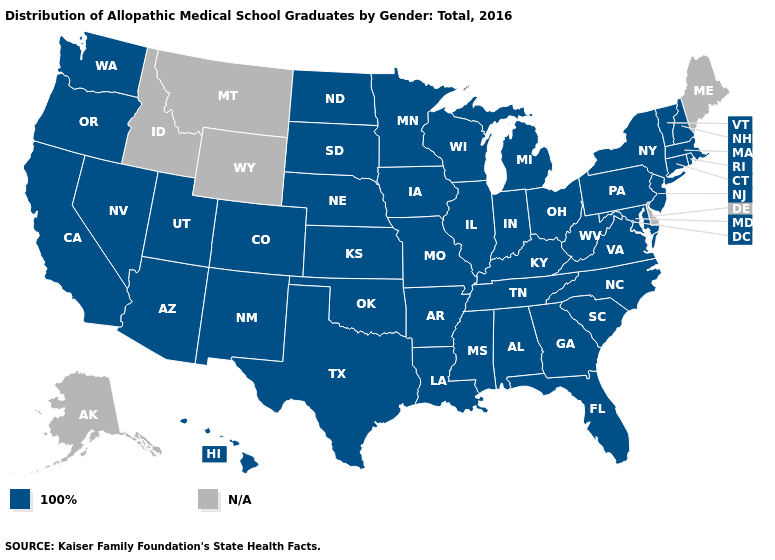What is the value of Florida?
Quick response, please. 100%. What is the lowest value in the USA?
Quick response, please. 100%. What is the value of South Dakota?
Be succinct. 100%. What is the value of California?
Short answer required. 100%. Is the legend a continuous bar?
Answer briefly. No. Which states have the lowest value in the USA?
Short answer required. Alabama, Arizona, Arkansas, California, Colorado, Connecticut, Florida, Georgia, Hawaii, Illinois, Indiana, Iowa, Kansas, Kentucky, Louisiana, Maryland, Massachusetts, Michigan, Minnesota, Mississippi, Missouri, Nebraska, Nevada, New Hampshire, New Jersey, New Mexico, New York, North Carolina, North Dakota, Ohio, Oklahoma, Oregon, Pennsylvania, Rhode Island, South Carolina, South Dakota, Tennessee, Texas, Utah, Vermont, Virginia, Washington, West Virginia, Wisconsin. Name the states that have a value in the range 100%?
Give a very brief answer. Alabama, Arizona, Arkansas, California, Colorado, Connecticut, Florida, Georgia, Hawaii, Illinois, Indiana, Iowa, Kansas, Kentucky, Louisiana, Maryland, Massachusetts, Michigan, Minnesota, Mississippi, Missouri, Nebraska, Nevada, New Hampshire, New Jersey, New Mexico, New York, North Carolina, North Dakota, Ohio, Oklahoma, Oregon, Pennsylvania, Rhode Island, South Carolina, South Dakota, Tennessee, Texas, Utah, Vermont, Virginia, Washington, West Virginia, Wisconsin. Which states have the highest value in the USA?
Keep it brief. Alabama, Arizona, Arkansas, California, Colorado, Connecticut, Florida, Georgia, Hawaii, Illinois, Indiana, Iowa, Kansas, Kentucky, Louisiana, Maryland, Massachusetts, Michigan, Minnesota, Mississippi, Missouri, Nebraska, Nevada, New Hampshire, New Jersey, New Mexico, New York, North Carolina, North Dakota, Ohio, Oklahoma, Oregon, Pennsylvania, Rhode Island, South Carolina, South Dakota, Tennessee, Texas, Utah, Vermont, Virginia, Washington, West Virginia, Wisconsin. What is the value of Vermont?
Write a very short answer. 100%. What is the highest value in the South ?
Write a very short answer. 100%. Name the states that have a value in the range 100%?
Short answer required. Alabama, Arizona, Arkansas, California, Colorado, Connecticut, Florida, Georgia, Hawaii, Illinois, Indiana, Iowa, Kansas, Kentucky, Louisiana, Maryland, Massachusetts, Michigan, Minnesota, Mississippi, Missouri, Nebraska, Nevada, New Hampshire, New Jersey, New Mexico, New York, North Carolina, North Dakota, Ohio, Oklahoma, Oregon, Pennsylvania, Rhode Island, South Carolina, South Dakota, Tennessee, Texas, Utah, Vermont, Virginia, Washington, West Virginia, Wisconsin. Name the states that have a value in the range N/A?
Give a very brief answer. Alaska, Delaware, Idaho, Maine, Montana, Wyoming. Does the first symbol in the legend represent the smallest category?
Give a very brief answer. Yes. 